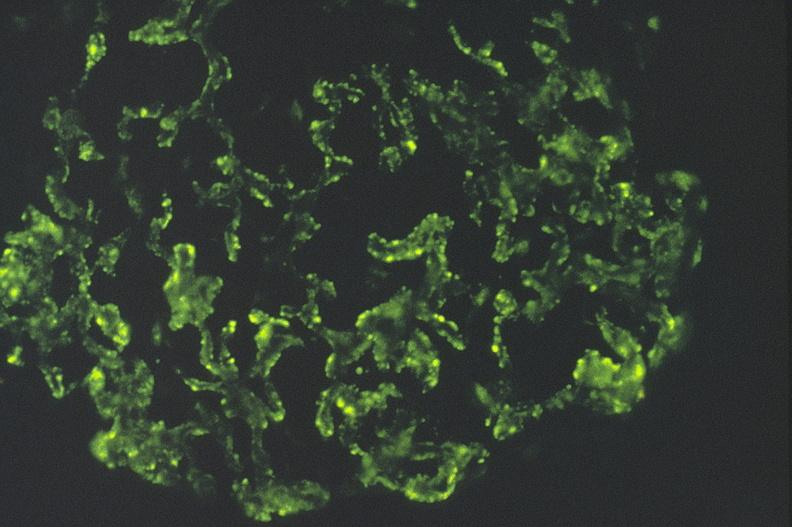s urinary present?
Answer the question using a single word or phrase. Yes 